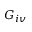<formula> <loc_0><loc_0><loc_500><loc_500>G _ { i v }</formula> 